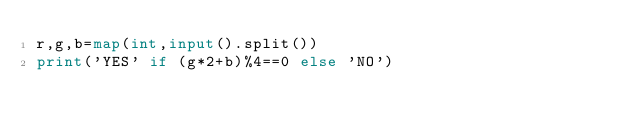Convert code to text. <code><loc_0><loc_0><loc_500><loc_500><_Python_>r,g,b=map(int,input().split())
print('YES' if (g*2+b)%4==0 else 'NO')</code> 